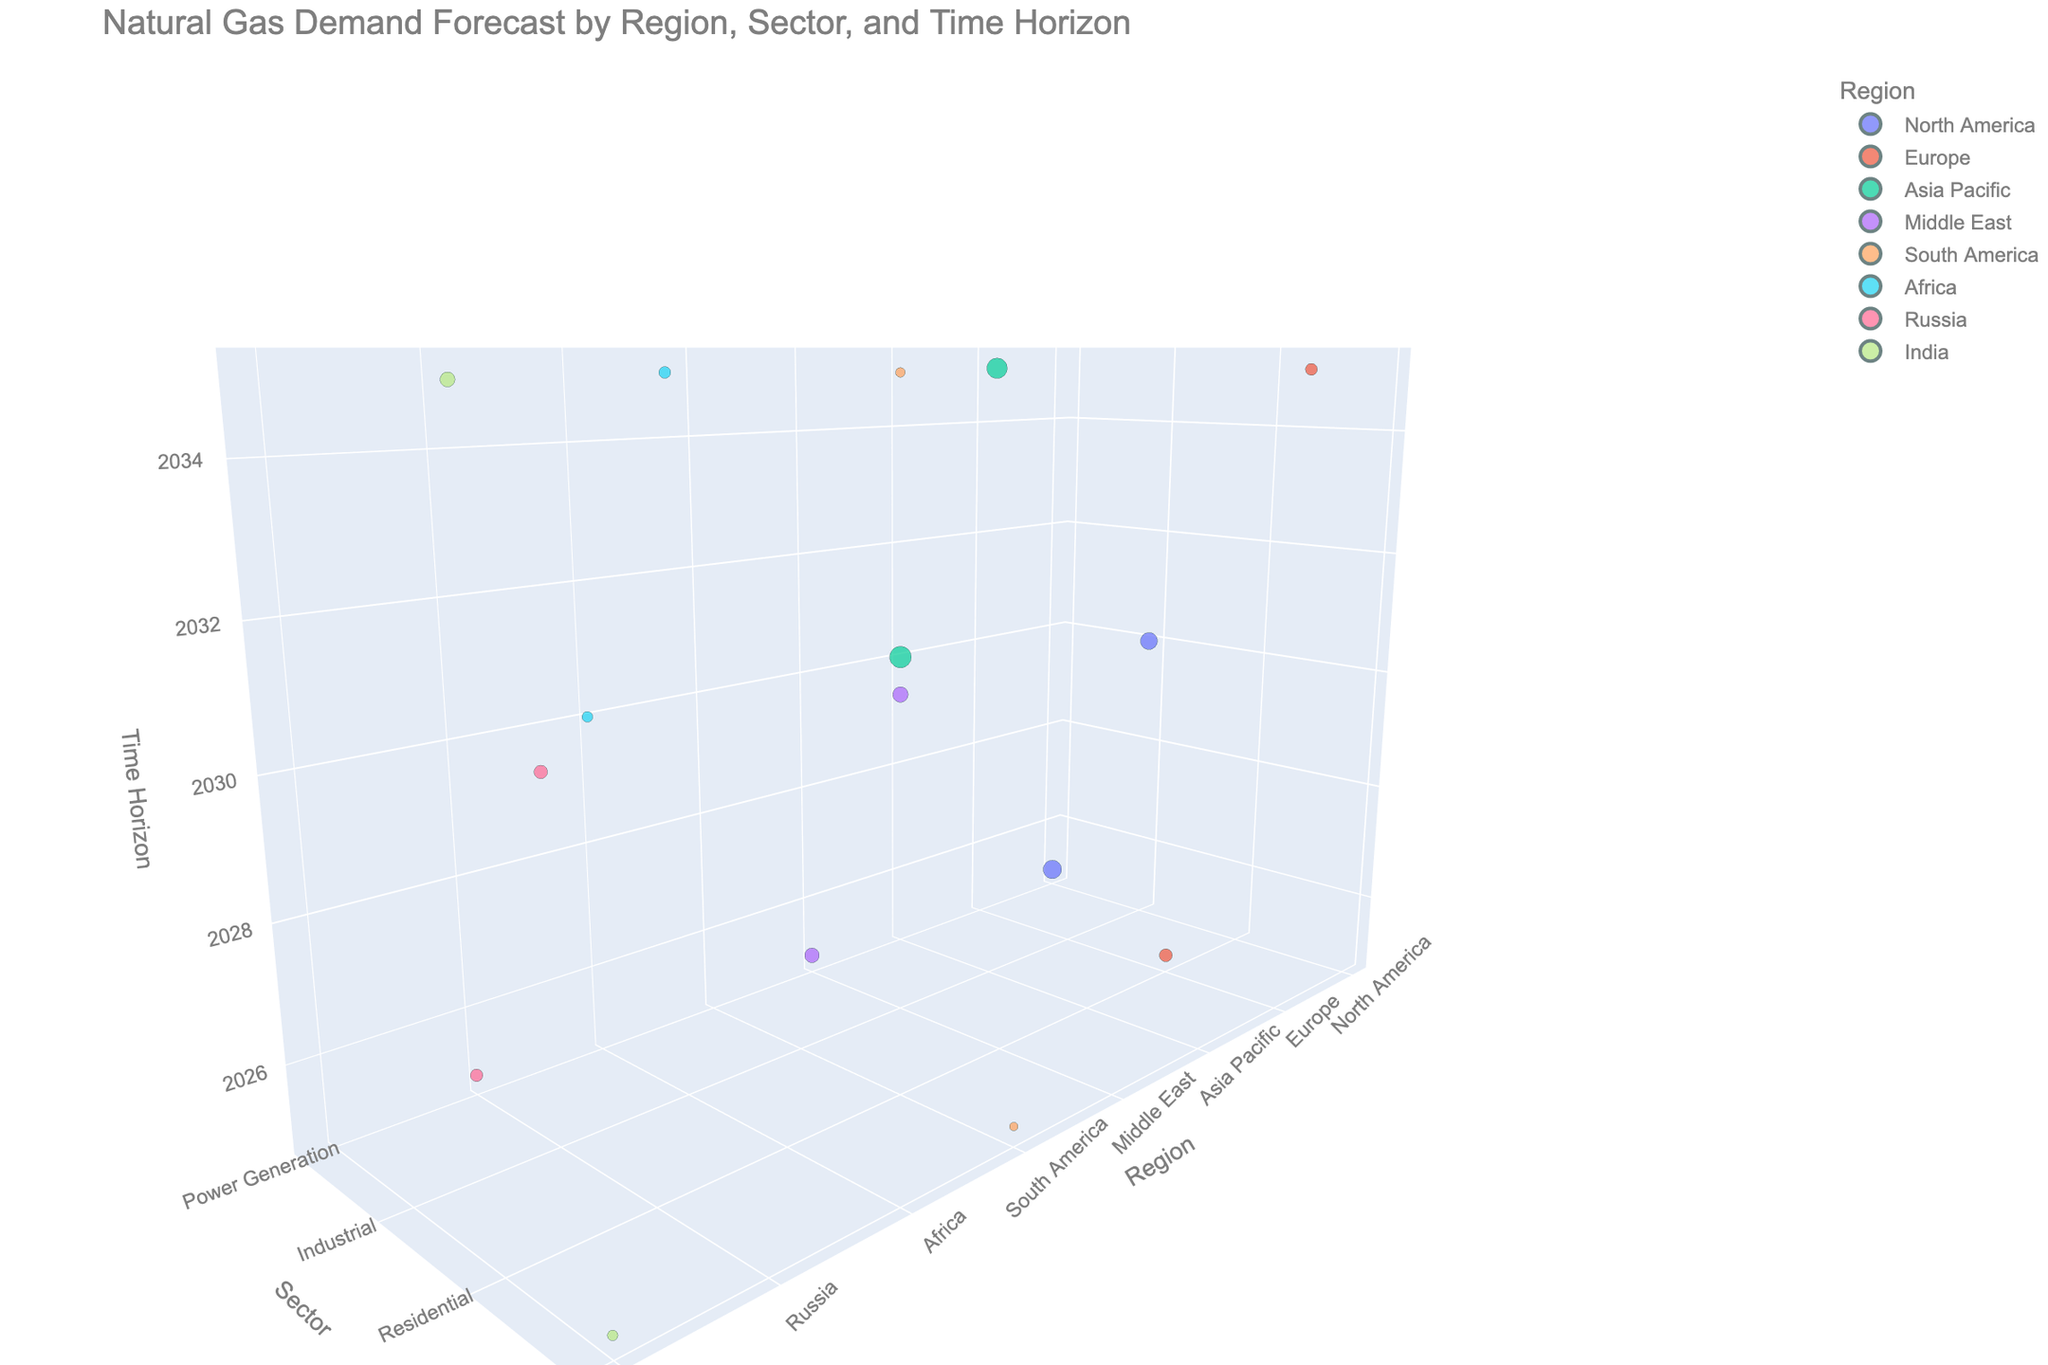what is the title of the chart? The title is displayed at the top of the chart, providing a summary of what the chart represents. In this case, it states the specific context of the data shown.
Answer: Natural Gas Demand Forecast by Region, Sector, and Time Horizon Which region has the highest demand for natural gas in 2030? First, identify the data points with a time horizon of 2030 and then compare the demand values. The highest value in 2030 is for Asia Pacific in the Power Generation sector.
Answer: Asia Pacific Are there more data points representing the Industrial sector or the Residential sector? Count the data points relevant to both sectors. Industrial sector has data points for North America, Asia Pacific, Middle East, Africa, and Russia, totaling 5. Residential sector has data points for Europe, South America, and India, totaling 3.
Answer: Industrial sector What is the smallest time horizon shown for the Residential sector? Look at the points corresponding to the Residential sector and find the smallest time horizon value among them. The Residential sector points are for Europe (2025), South America, and India. 2025 is the earliest time horizon.
Answer: 2025 Which sector in North America has the highest forecasted demand in 2025? Check the data points that belong to North America and the year 2025. Compare the sectoral demand values for this year. Power Generation has a demand of 45.2 BCF/day, which is higher than other sectors.
Answer: Power Generation What is the average demand of the Industrial sector in 2035? Identify the data points for the Industrial sector in 2035. The countries included are Asia Pacific and Africa. Calculate the average value by summing the demands (55.8 + 18.6) and dividing by 2. (55.8 + 18.6) / 2 = 37.2 BCF/day.
Answer: 37.2 BCF/day Compare the demand for the Power Generation sector in 2030 between Asia Pacific and Africa. Which region has a higher demand? Check the data points for the Power Generation sector in 2030. Compare the values for Asia Pacific (62.5 BCF/day) and Africa (15.3 BCF/day). Asia Pacific has a significantly higher demand.
Answer: Asia Pacific For which region and sector combination is the demand approximately 9.7 BCF/day for 2025? Look at the data points for the year 2025 and locate the combination where demand is close to 9.7 BCF/day. South America in the Commercial sector meets this criteria.
Answer: South America, Commercial sector Determine the highest demand forecasted for the Residential sector in 2035. Examine the data points for the Residential sector in 2035. The relevant regions are South America and India. The highest demand between these two points is 30.2 BCF/day for India.
Answer: India 